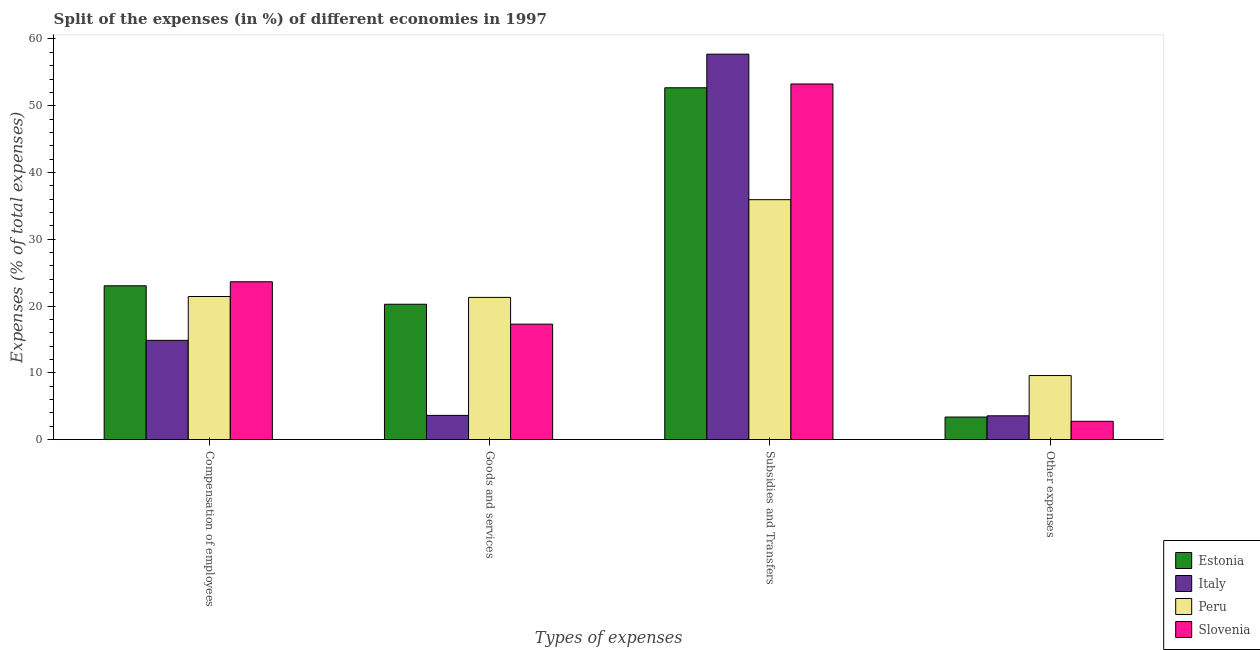How many different coloured bars are there?
Provide a succinct answer. 4. Are the number of bars per tick equal to the number of legend labels?
Make the answer very short. Yes. What is the label of the 2nd group of bars from the left?
Ensure brevity in your answer.  Goods and services. What is the percentage of amount spent on other expenses in Slovenia?
Your response must be concise. 2.74. Across all countries, what is the maximum percentage of amount spent on goods and services?
Your answer should be compact. 21.3. Across all countries, what is the minimum percentage of amount spent on subsidies?
Offer a terse response. 35.93. In which country was the percentage of amount spent on compensation of employees maximum?
Ensure brevity in your answer.  Slovenia. In which country was the percentage of amount spent on compensation of employees minimum?
Your answer should be very brief. Italy. What is the total percentage of amount spent on other expenses in the graph?
Ensure brevity in your answer.  19.28. What is the difference between the percentage of amount spent on goods and services in Estonia and that in Italy?
Keep it short and to the point. 16.65. What is the difference between the percentage of amount spent on compensation of employees in Estonia and the percentage of amount spent on other expenses in Slovenia?
Ensure brevity in your answer.  20.29. What is the average percentage of amount spent on goods and services per country?
Your response must be concise. 15.62. What is the difference between the percentage of amount spent on compensation of employees and percentage of amount spent on other expenses in Slovenia?
Make the answer very short. 20.9. In how many countries, is the percentage of amount spent on other expenses greater than 58 %?
Ensure brevity in your answer.  0. What is the ratio of the percentage of amount spent on subsidies in Slovenia to that in Italy?
Your answer should be very brief. 0.92. Is the percentage of amount spent on other expenses in Slovenia less than that in Estonia?
Your answer should be compact. Yes. Is the difference between the percentage of amount spent on subsidies in Peru and Estonia greater than the difference between the percentage of amount spent on goods and services in Peru and Estonia?
Keep it short and to the point. No. What is the difference between the highest and the second highest percentage of amount spent on compensation of employees?
Offer a terse response. 0.61. What is the difference between the highest and the lowest percentage of amount spent on goods and services?
Your response must be concise. 17.67. In how many countries, is the percentage of amount spent on other expenses greater than the average percentage of amount spent on other expenses taken over all countries?
Provide a succinct answer. 1. Is it the case that in every country, the sum of the percentage of amount spent on other expenses and percentage of amount spent on subsidies is greater than the sum of percentage of amount spent on compensation of employees and percentage of amount spent on goods and services?
Provide a succinct answer. Yes. What does the 4th bar from the left in Other expenses represents?
Ensure brevity in your answer.  Slovenia. What does the 4th bar from the right in Subsidies and Transfers represents?
Your answer should be compact. Estonia. Is it the case that in every country, the sum of the percentage of amount spent on compensation of employees and percentage of amount spent on goods and services is greater than the percentage of amount spent on subsidies?
Provide a succinct answer. No. How many bars are there?
Give a very brief answer. 16. Are all the bars in the graph horizontal?
Ensure brevity in your answer.  No. What is the difference between two consecutive major ticks on the Y-axis?
Keep it short and to the point. 10. Are the values on the major ticks of Y-axis written in scientific E-notation?
Your answer should be compact. No. Does the graph contain any zero values?
Provide a short and direct response. No. Where does the legend appear in the graph?
Provide a succinct answer. Bottom right. How are the legend labels stacked?
Your response must be concise. Vertical. What is the title of the graph?
Provide a short and direct response. Split of the expenses (in %) of different economies in 1997. Does "Poland" appear as one of the legend labels in the graph?
Your answer should be compact. No. What is the label or title of the X-axis?
Offer a terse response. Types of expenses. What is the label or title of the Y-axis?
Offer a terse response. Expenses (% of total expenses). What is the Expenses (% of total expenses) of Estonia in Compensation of employees?
Keep it short and to the point. 23.03. What is the Expenses (% of total expenses) of Italy in Compensation of employees?
Your response must be concise. 14.87. What is the Expenses (% of total expenses) in Peru in Compensation of employees?
Your answer should be very brief. 21.43. What is the Expenses (% of total expenses) in Slovenia in Compensation of employees?
Provide a succinct answer. 23.64. What is the Expenses (% of total expenses) in Estonia in Goods and services?
Ensure brevity in your answer.  20.27. What is the Expenses (% of total expenses) in Italy in Goods and services?
Provide a short and direct response. 3.63. What is the Expenses (% of total expenses) in Peru in Goods and services?
Provide a short and direct response. 21.3. What is the Expenses (% of total expenses) in Slovenia in Goods and services?
Your answer should be very brief. 17.29. What is the Expenses (% of total expenses) of Estonia in Subsidies and Transfers?
Make the answer very short. 52.69. What is the Expenses (% of total expenses) of Italy in Subsidies and Transfers?
Your answer should be compact. 57.73. What is the Expenses (% of total expenses) in Peru in Subsidies and Transfers?
Provide a short and direct response. 35.93. What is the Expenses (% of total expenses) of Slovenia in Subsidies and Transfers?
Keep it short and to the point. 53.26. What is the Expenses (% of total expenses) in Estonia in Other expenses?
Your answer should be compact. 3.38. What is the Expenses (% of total expenses) in Italy in Other expenses?
Offer a very short reply. 3.56. What is the Expenses (% of total expenses) in Peru in Other expenses?
Offer a very short reply. 9.59. What is the Expenses (% of total expenses) of Slovenia in Other expenses?
Ensure brevity in your answer.  2.74. Across all Types of expenses, what is the maximum Expenses (% of total expenses) of Estonia?
Your answer should be very brief. 52.69. Across all Types of expenses, what is the maximum Expenses (% of total expenses) in Italy?
Ensure brevity in your answer.  57.73. Across all Types of expenses, what is the maximum Expenses (% of total expenses) in Peru?
Provide a succinct answer. 35.93. Across all Types of expenses, what is the maximum Expenses (% of total expenses) of Slovenia?
Provide a short and direct response. 53.26. Across all Types of expenses, what is the minimum Expenses (% of total expenses) of Estonia?
Your answer should be compact. 3.38. Across all Types of expenses, what is the minimum Expenses (% of total expenses) of Italy?
Your response must be concise. 3.56. Across all Types of expenses, what is the minimum Expenses (% of total expenses) of Peru?
Ensure brevity in your answer.  9.59. Across all Types of expenses, what is the minimum Expenses (% of total expenses) in Slovenia?
Give a very brief answer. 2.74. What is the total Expenses (% of total expenses) of Estonia in the graph?
Your answer should be very brief. 99.38. What is the total Expenses (% of total expenses) of Italy in the graph?
Give a very brief answer. 79.78. What is the total Expenses (% of total expenses) of Peru in the graph?
Ensure brevity in your answer.  88.25. What is the total Expenses (% of total expenses) of Slovenia in the graph?
Keep it short and to the point. 96.93. What is the difference between the Expenses (% of total expenses) of Estonia in Compensation of employees and that in Goods and services?
Your answer should be very brief. 2.76. What is the difference between the Expenses (% of total expenses) in Italy in Compensation of employees and that in Goods and services?
Ensure brevity in your answer.  11.24. What is the difference between the Expenses (% of total expenses) of Peru in Compensation of employees and that in Goods and services?
Your answer should be very brief. 0.13. What is the difference between the Expenses (% of total expenses) in Slovenia in Compensation of employees and that in Goods and services?
Your response must be concise. 6.35. What is the difference between the Expenses (% of total expenses) of Estonia in Compensation of employees and that in Subsidies and Transfers?
Provide a short and direct response. -29.66. What is the difference between the Expenses (% of total expenses) in Italy in Compensation of employees and that in Subsidies and Transfers?
Your answer should be compact. -42.86. What is the difference between the Expenses (% of total expenses) of Peru in Compensation of employees and that in Subsidies and Transfers?
Your answer should be compact. -14.5. What is the difference between the Expenses (% of total expenses) in Slovenia in Compensation of employees and that in Subsidies and Transfers?
Ensure brevity in your answer.  -29.62. What is the difference between the Expenses (% of total expenses) in Estonia in Compensation of employees and that in Other expenses?
Offer a very short reply. 19.66. What is the difference between the Expenses (% of total expenses) of Italy in Compensation of employees and that in Other expenses?
Provide a short and direct response. 11.3. What is the difference between the Expenses (% of total expenses) in Peru in Compensation of employees and that in Other expenses?
Provide a short and direct response. 11.84. What is the difference between the Expenses (% of total expenses) in Slovenia in Compensation of employees and that in Other expenses?
Make the answer very short. 20.9. What is the difference between the Expenses (% of total expenses) in Estonia in Goods and services and that in Subsidies and Transfers?
Your response must be concise. -32.42. What is the difference between the Expenses (% of total expenses) in Italy in Goods and services and that in Subsidies and Transfers?
Ensure brevity in your answer.  -54.1. What is the difference between the Expenses (% of total expenses) of Peru in Goods and services and that in Subsidies and Transfers?
Offer a very short reply. -14.63. What is the difference between the Expenses (% of total expenses) in Slovenia in Goods and services and that in Subsidies and Transfers?
Your answer should be compact. -35.97. What is the difference between the Expenses (% of total expenses) of Estonia in Goods and services and that in Other expenses?
Offer a terse response. 16.89. What is the difference between the Expenses (% of total expenses) in Italy in Goods and services and that in Other expenses?
Offer a very short reply. 0.06. What is the difference between the Expenses (% of total expenses) of Peru in Goods and services and that in Other expenses?
Give a very brief answer. 11.7. What is the difference between the Expenses (% of total expenses) of Slovenia in Goods and services and that in Other expenses?
Your answer should be compact. 14.55. What is the difference between the Expenses (% of total expenses) of Estonia in Subsidies and Transfers and that in Other expenses?
Your answer should be compact. 49.31. What is the difference between the Expenses (% of total expenses) in Italy in Subsidies and Transfers and that in Other expenses?
Provide a succinct answer. 54.16. What is the difference between the Expenses (% of total expenses) in Peru in Subsidies and Transfers and that in Other expenses?
Ensure brevity in your answer.  26.34. What is the difference between the Expenses (% of total expenses) of Slovenia in Subsidies and Transfers and that in Other expenses?
Provide a succinct answer. 50.52. What is the difference between the Expenses (% of total expenses) in Estonia in Compensation of employees and the Expenses (% of total expenses) in Italy in Goods and services?
Provide a short and direct response. 19.41. What is the difference between the Expenses (% of total expenses) in Estonia in Compensation of employees and the Expenses (% of total expenses) in Peru in Goods and services?
Ensure brevity in your answer.  1.74. What is the difference between the Expenses (% of total expenses) in Estonia in Compensation of employees and the Expenses (% of total expenses) in Slovenia in Goods and services?
Offer a terse response. 5.74. What is the difference between the Expenses (% of total expenses) in Italy in Compensation of employees and the Expenses (% of total expenses) in Peru in Goods and services?
Ensure brevity in your answer.  -6.43. What is the difference between the Expenses (% of total expenses) of Italy in Compensation of employees and the Expenses (% of total expenses) of Slovenia in Goods and services?
Your answer should be compact. -2.43. What is the difference between the Expenses (% of total expenses) of Peru in Compensation of employees and the Expenses (% of total expenses) of Slovenia in Goods and services?
Your answer should be very brief. 4.14. What is the difference between the Expenses (% of total expenses) in Estonia in Compensation of employees and the Expenses (% of total expenses) in Italy in Subsidies and Transfers?
Provide a short and direct response. -34.69. What is the difference between the Expenses (% of total expenses) in Estonia in Compensation of employees and the Expenses (% of total expenses) in Peru in Subsidies and Transfers?
Ensure brevity in your answer.  -12.9. What is the difference between the Expenses (% of total expenses) in Estonia in Compensation of employees and the Expenses (% of total expenses) in Slovenia in Subsidies and Transfers?
Provide a short and direct response. -30.22. What is the difference between the Expenses (% of total expenses) of Italy in Compensation of employees and the Expenses (% of total expenses) of Peru in Subsidies and Transfers?
Offer a very short reply. -21.07. What is the difference between the Expenses (% of total expenses) of Italy in Compensation of employees and the Expenses (% of total expenses) of Slovenia in Subsidies and Transfers?
Your response must be concise. -38.39. What is the difference between the Expenses (% of total expenses) of Peru in Compensation of employees and the Expenses (% of total expenses) of Slovenia in Subsidies and Transfers?
Offer a very short reply. -31.83. What is the difference between the Expenses (% of total expenses) of Estonia in Compensation of employees and the Expenses (% of total expenses) of Italy in Other expenses?
Your response must be concise. 19.47. What is the difference between the Expenses (% of total expenses) in Estonia in Compensation of employees and the Expenses (% of total expenses) in Peru in Other expenses?
Your response must be concise. 13.44. What is the difference between the Expenses (% of total expenses) of Estonia in Compensation of employees and the Expenses (% of total expenses) of Slovenia in Other expenses?
Provide a short and direct response. 20.29. What is the difference between the Expenses (% of total expenses) in Italy in Compensation of employees and the Expenses (% of total expenses) in Peru in Other expenses?
Offer a terse response. 5.27. What is the difference between the Expenses (% of total expenses) of Italy in Compensation of employees and the Expenses (% of total expenses) of Slovenia in Other expenses?
Offer a terse response. 12.12. What is the difference between the Expenses (% of total expenses) of Peru in Compensation of employees and the Expenses (% of total expenses) of Slovenia in Other expenses?
Ensure brevity in your answer.  18.69. What is the difference between the Expenses (% of total expenses) in Estonia in Goods and services and the Expenses (% of total expenses) in Italy in Subsidies and Transfers?
Make the answer very short. -37.45. What is the difference between the Expenses (% of total expenses) of Estonia in Goods and services and the Expenses (% of total expenses) of Peru in Subsidies and Transfers?
Offer a very short reply. -15.66. What is the difference between the Expenses (% of total expenses) in Estonia in Goods and services and the Expenses (% of total expenses) in Slovenia in Subsidies and Transfers?
Offer a very short reply. -32.99. What is the difference between the Expenses (% of total expenses) in Italy in Goods and services and the Expenses (% of total expenses) in Peru in Subsidies and Transfers?
Provide a succinct answer. -32.31. What is the difference between the Expenses (% of total expenses) in Italy in Goods and services and the Expenses (% of total expenses) in Slovenia in Subsidies and Transfers?
Ensure brevity in your answer.  -49.63. What is the difference between the Expenses (% of total expenses) of Peru in Goods and services and the Expenses (% of total expenses) of Slovenia in Subsidies and Transfers?
Your response must be concise. -31.96. What is the difference between the Expenses (% of total expenses) in Estonia in Goods and services and the Expenses (% of total expenses) in Italy in Other expenses?
Provide a short and direct response. 16.71. What is the difference between the Expenses (% of total expenses) of Estonia in Goods and services and the Expenses (% of total expenses) of Peru in Other expenses?
Offer a very short reply. 10.68. What is the difference between the Expenses (% of total expenses) of Estonia in Goods and services and the Expenses (% of total expenses) of Slovenia in Other expenses?
Provide a short and direct response. 17.53. What is the difference between the Expenses (% of total expenses) of Italy in Goods and services and the Expenses (% of total expenses) of Peru in Other expenses?
Offer a terse response. -5.97. What is the difference between the Expenses (% of total expenses) in Italy in Goods and services and the Expenses (% of total expenses) in Slovenia in Other expenses?
Your answer should be compact. 0.88. What is the difference between the Expenses (% of total expenses) in Peru in Goods and services and the Expenses (% of total expenses) in Slovenia in Other expenses?
Your answer should be compact. 18.55. What is the difference between the Expenses (% of total expenses) of Estonia in Subsidies and Transfers and the Expenses (% of total expenses) of Italy in Other expenses?
Your answer should be very brief. 49.13. What is the difference between the Expenses (% of total expenses) in Estonia in Subsidies and Transfers and the Expenses (% of total expenses) in Peru in Other expenses?
Offer a very short reply. 43.1. What is the difference between the Expenses (% of total expenses) of Estonia in Subsidies and Transfers and the Expenses (% of total expenses) of Slovenia in Other expenses?
Your response must be concise. 49.95. What is the difference between the Expenses (% of total expenses) in Italy in Subsidies and Transfers and the Expenses (% of total expenses) in Peru in Other expenses?
Your answer should be very brief. 48.13. What is the difference between the Expenses (% of total expenses) in Italy in Subsidies and Transfers and the Expenses (% of total expenses) in Slovenia in Other expenses?
Make the answer very short. 54.98. What is the difference between the Expenses (% of total expenses) of Peru in Subsidies and Transfers and the Expenses (% of total expenses) of Slovenia in Other expenses?
Make the answer very short. 33.19. What is the average Expenses (% of total expenses) in Estonia per Types of expenses?
Give a very brief answer. 24.84. What is the average Expenses (% of total expenses) of Italy per Types of expenses?
Offer a very short reply. 19.95. What is the average Expenses (% of total expenses) in Peru per Types of expenses?
Ensure brevity in your answer.  22.06. What is the average Expenses (% of total expenses) of Slovenia per Types of expenses?
Offer a terse response. 24.23. What is the difference between the Expenses (% of total expenses) in Estonia and Expenses (% of total expenses) in Italy in Compensation of employees?
Give a very brief answer. 8.17. What is the difference between the Expenses (% of total expenses) of Estonia and Expenses (% of total expenses) of Peru in Compensation of employees?
Give a very brief answer. 1.61. What is the difference between the Expenses (% of total expenses) in Estonia and Expenses (% of total expenses) in Slovenia in Compensation of employees?
Your response must be concise. -0.61. What is the difference between the Expenses (% of total expenses) in Italy and Expenses (% of total expenses) in Peru in Compensation of employees?
Your answer should be very brief. -6.56. What is the difference between the Expenses (% of total expenses) in Italy and Expenses (% of total expenses) in Slovenia in Compensation of employees?
Keep it short and to the point. -8.77. What is the difference between the Expenses (% of total expenses) of Peru and Expenses (% of total expenses) of Slovenia in Compensation of employees?
Your answer should be very brief. -2.21. What is the difference between the Expenses (% of total expenses) of Estonia and Expenses (% of total expenses) of Italy in Goods and services?
Provide a succinct answer. 16.65. What is the difference between the Expenses (% of total expenses) in Estonia and Expenses (% of total expenses) in Peru in Goods and services?
Provide a short and direct response. -1.03. What is the difference between the Expenses (% of total expenses) of Estonia and Expenses (% of total expenses) of Slovenia in Goods and services?
Your answer should be compact. 2.98. What is the difference between the Expenses (% of total expenses) in Italy and Expenses (% of total expenses) in Peru in Goods and services?
Give a very brief answer. -17.67. What is the difference between the Expenses (% of total expenses) of Italy and Expenses (% of total expenses) of Slovenia in Goods and services?
Keep it short and to the point. -13.67. What is the difference between the Expenses (% of total expenses) in Peru and Expenses (% of total expenses) in Slovenia in Goods and services?
Offer a terse response. 4.01. What is the difference between the Expenses (% of total expenses) of Estonia and Expenses (% of total expenses) of Italy in Subsidies and Transfers?
Offer a terse response. -5.03. What is the difference between the Expenses (% of total expenses) of Estonia and Expenses (% of total expenses) of Peru in Subsidies and Transfers?
Your answer should be compact. 16.76. What is the difference between the Expenses (% of total expenses) of Estonia and Expenses (% of total expenses) of Slovenia in Subsidies and Transfers?
Your response must be concise. -0.57. What is the difference between the Expenses (% of total expenses) in Italy and Expenses (% of total expenses) in Peru in Subsidies and Transfers?
Make the answer very short. 21.79. What is the difference between the Expenses (% of total expenses) in Italy and Expenses (% of total expenses) in Slovenia in Subsidies and Transfers?
Your response must be concise. 4.47. What is the difference between the Expenses (% of total expenses) in Peru and Expenses (% of total expenses) in Slovenia in Subsidies and Transfers?
Ensure brevity in your answer.  -17.33. What is the difference between the Expenses (% of total expenses) in Estonia and Expenses (% of total expenses) in Italy in Other expenses?
Provide a succinct answer. -0.18. What is the difference between the Expenses (% of total expenses) of Estonia and Expenses (% of total expenses) of Peru in Other expenses?
Offer a very short reply. -6.21. What is the difference between the Expenses (% of total expenses) of Estonia and Expenses (% of total expenses) of Slovenia in Other expenses?
Keep it short and to the point. 0.64. What is the difference between the Expenses (% of total expenses) of Italy and Expenses (% of total expenses) of Peru in Other expenses?
Keep it short and to the point. -6.03. What is the difference between the Expenses (% of total expenses) of Italy and Expenses (% of total expenses) of Slovenia in Other expenses?
Your answer should be very brief. 0.82. What is the difference between the Expenses (% of total expenses) of Peru and Expenses (% of total expenses) of Slovenia in Other expenses?
Offer a very short reply. 6.85. What is the ratio of the Expenses (% of total expenses) in Estonia in Compensation of employees to that in Goods and services?
Keep it short and to the point. 1.14. What is the ratio of the Expenses (% of total expenses) in Italy in Compensation of employees to that in Goods and services?
Offer a terse response. 4.1. What is the ratio of the Expenses (% of total expenses) of Peru in Compensation of employees to that in Goods and services?
Keep it short and to the point. 1.01. What is the ratio of the Expenses (% of total expenses) of Slovenia in Compensation of employees to that in Goods and services?
Your answer should be very brief. 1.37. What is the ratio of the Expenses (% of total expenses) in Estonia in Compensation of employees to that in Subsidies and Transfers?
Ensure brevity in your answer.  0.44. What is the ratio of the Expenses (% of total expenses) in Italy in Compensation of employees to that in Subsidies and Transfers?
Offer a very short reply. 0.26. What is the ratio of the Expenses (% of total expenses) of Peru in Compensation of employees to that in Subsidies and Transfers?
Provide a short and direct response. 0.6. What is the ratio of the Expenses (% of total expenses) in Slovenia in Compensation of employees to that in Subsidies and Transfers?
Your answer should be compact. 0.44. What is the ratio of the Expenses (% of total expenses) of Estonia in Compensation of employees to that in Other expenses?
Make the answer very short. 6.82. What is the ratio of the Expenses (% of total expenses) in Italy in Compensation of employees to that in Other expenses?
Make the answer very short. 4.17. What is the ratio of the Expenses (% of total expenses) in Peru in Compensation of employees to that in Other expenses?
Provide a succinct answer. 2.23. What is the ratio of the Expenses (% of total expenses) of Slovenia in Compensation of employees to that in Other expenses?
Offer a terse response. 8.62. What is the ratio of the Expenses (% of total expenses) in Estonia in Goods and services to that in Subsidies and Transfers?
Give a very brief answer. 0.38. What is the ratio of the Expenses (% of total expenses) in Italy in Goods and services to that in Subsidies and Transfers?
Make the answer very short. 0.06. What is the ratio of the Expenses (% of total expenses) of Peru in Goods and services to that in Subsidies and Transfers?
Offer a very short reply. 0.59. What is the ratio of the Expenses (% of total expenses) of Slovenia in Goods and services to that in Subsidies and Transfers?
Give a very brief answer. 0.32. What is the ratio of the Expenses (% of total expenses) of Estonia in Goods and services to that in Other expenses?
Provide a short and direct response. 6. What is the ratio of the Expenses (% of total expenses) in Italy in Goods and services to that in Other expenses?
Provide a short and direct response. 1.02. What is the ratio of the Expenses (% of total expenses) in Peru in Goods and services to that in Other expenses?
Provide a short and direct response. 2.22. What is the ratio of the Expenses (% of total expenses) of Slovenia in Goods and services to that in Other expenses?
Give a very brief answer. 6.3. What is the ratio of the Expenses (% of total expenses) in Estonia in Subsidies and Transfers to that in Other expenses?
Offer a terse response. 15.6. What is the ratio of the Expenses (% of total expenses) in Italy in Subsidies and Transfers to that in Other expenses?
Offer a very short reply. 16.2. What is the ratio of the Expenses (% of total expenses) in Peru in Subsidies and Transfers to that in Other expenses?
Your answer should be very brief. 3.75. What is the ratio of the Expenses (% of total expenses) in Slovenia in Subsidies and Transfers to that in Other expenses?
Keep it short and to the point. 19.42. What is the difference between the highest and the second highest Expenses (% of total expenses) in Estonia?
Ensure brevity in your answer.  29.66. What is the difference between the highest and the second highest Expenses (% of total expenses) in Italy?
Your response must be concise. 42.86. What is the difference between the highest and the second highest Expenses (% of total expenses) of Peru?
Keep it short and to the point. 14.5. What is the difference between the highest and the second highest Expenses (% of total expenses) of Slovenia?
Ensure brevity in your answer.  29.62. What is the difference between the highest and the lowest Expenses (% of total expenses) in Estonia?
Keep it short and to the point. 49.31. What is the difference between the highest and the lowest Expenses (% of total expenses) in Italy?
Ensure brevity in your answer.  54.16. What is the difference between the highest and the lowest Expenses (% of total expenses) of Peru?
Provide a succinct answer. 26.34. What is the difference between the highest and the lowest Expenses (% of total expenses) of Slovenia?
Offer a terse response. 50.52. 